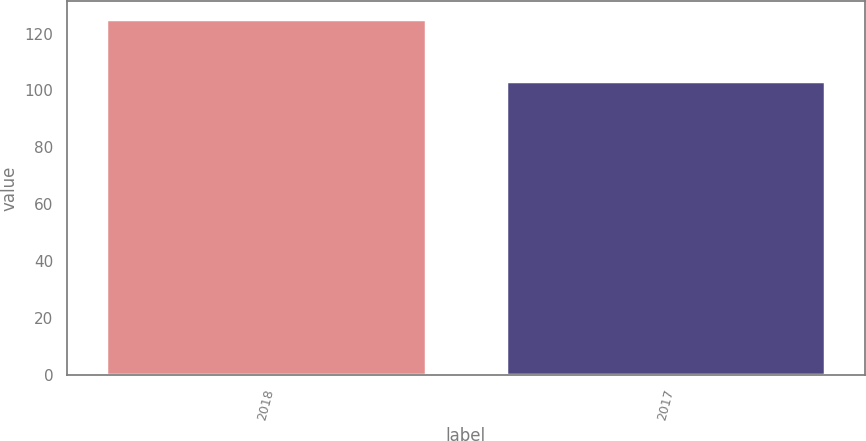Convert chart. <chart><loc_0><loc_0><loc_500><loc_500><bar_chart><fcel>2018<fcel>2017<nl><fcel>125.09<fcel>103.36<nl></chart> 